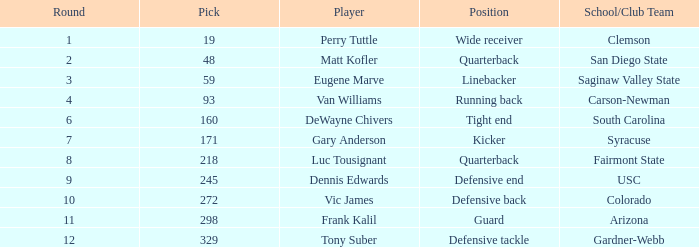Who occupies the linebacker position? Eugene Marve. 